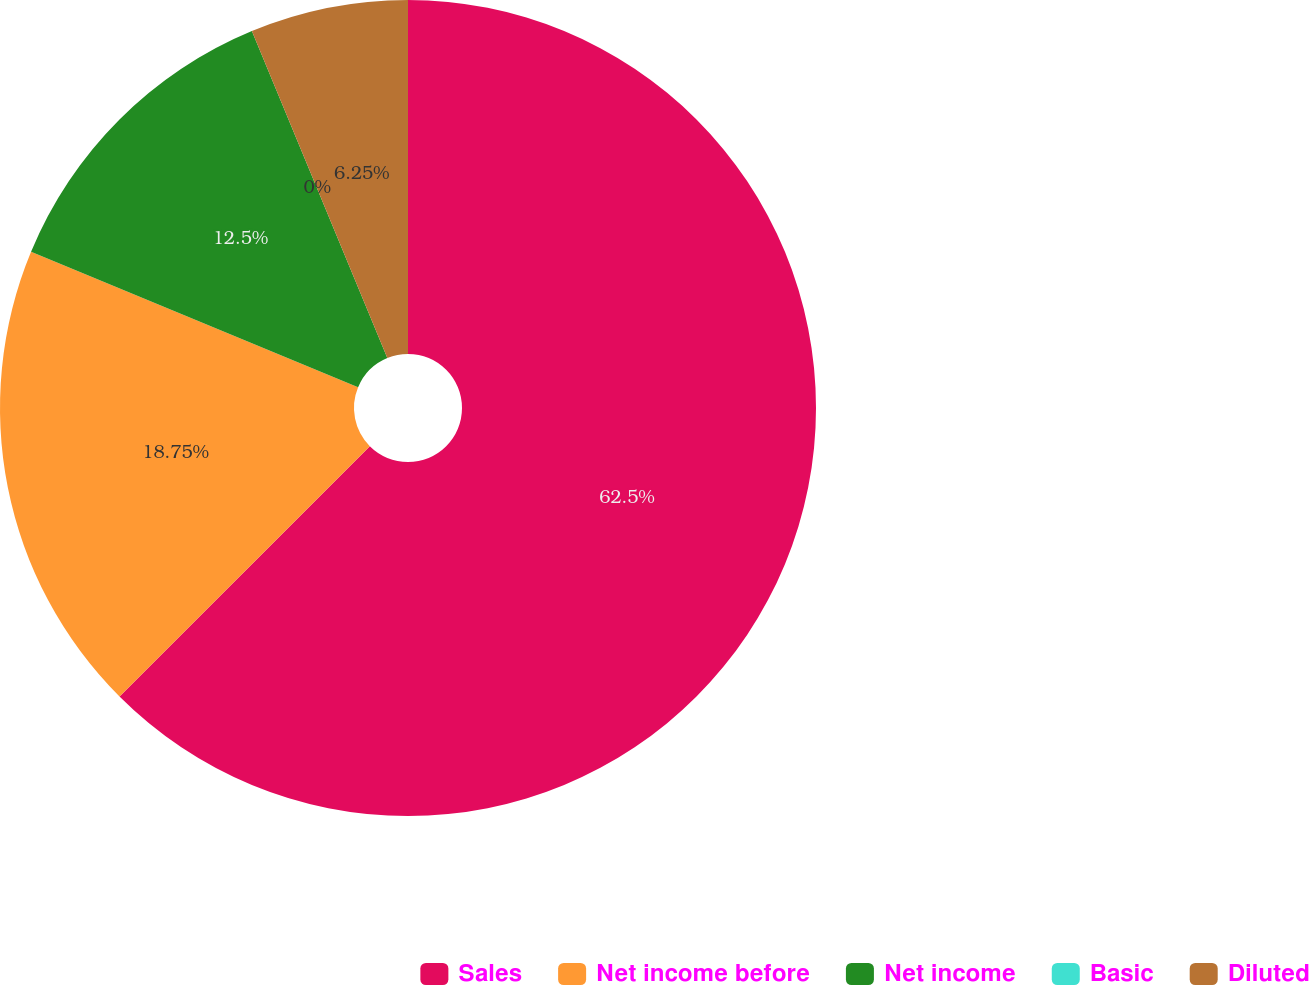Convert chart to OTSL. <chart><loc_0><loc_0><loc_500><loc_500><pie_chart><fcel>Sales<fcel>Net income before<fcel>Net income<fcel>Basic<fcel>Diluted<nl><fcel>62.5%<fcel>18.75%<fcel>12.5%<fcel>0.0%<fcel>6.25%<nl></chart> 